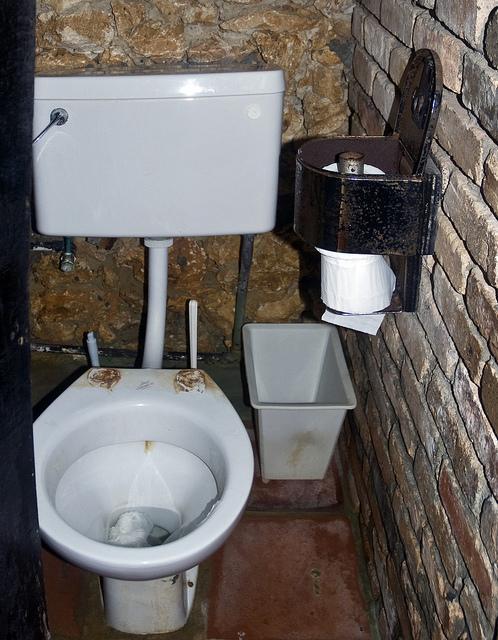How many toilets can be seen?
Give a very brief answer. 1. How many people are in the photo?
Give a very brief answer. 0. 